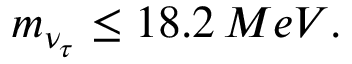<formula> <loc_0><loc_0><loc_500><loc_500>m _ { \nu _ { \tau } } \leq 1 8 . 2 \, M e V .</formula> 